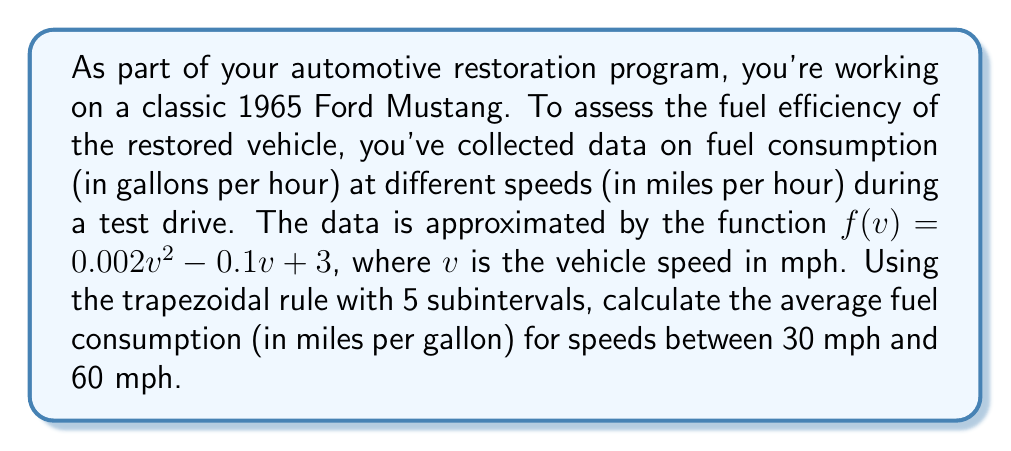What is the answer to this math problem? To solve this problem, we'll follow these steps:

1) The fuel efficiency (miles per gallon) is the inverse of fuel consumption (gallons per mile). We need to integrate $\frac{1}{f(v)}$ with respect to $v$.

2) We'll use the trapezoidal rule with 5 subintervals. The formula is:

   $$\int_{a}^{b} g(x) dx \approx \frac{h}{2}[g(x_0) + 2g(x_1) + 2g(x_2) + 2g(x_3) + 2g(x_4) + g(x_5)]$$

   where $h = \frac{b-a}{n}$, $n$ is the number of subintervals, and $x_i = a + ih$.

3) In our case, $a = 30$, $b = 60$, $n = 5$, so $h = \frac{60-30}{5} = 6$.

4) We need to evaluate $g(v) = \frac{1}{f(v)} = \frac{1}{0.002v^2 - 0.1v + 3}$ at $v = 30, 36, 42, 48, 54, 60$.

5) Calculating these values:
   $g(30) = \frac{1}{0.002(30)^2 - 0.1(30) + 3} = 0.4545$
   $g(36) = 0.4926$
   $g(42) = 0.5102$
   $g(48) = 0.5051$
   $g(54) = 0.4808$
   $g(60) = 0.4444$

6) Applying the trapezoidal rule:
   $$\int_{30}^{60} \frac{1}{f(v)} dv \approx \frac{6}{2}[0.4545 + 2(0.4926 + 0.5102 + 0.5051 + 0.4808) + 0.4444]$$
   $$= 3[0.4545 + 3.9774 + 0.4444] = 3(4.8763) = 14.6289$$

7) This integral represents the total miles driven per gallon of fuel consumed. To get the average fuel efficiency, we divide by the speed range (60 - 30 = 30 mph):

   Average MPG = $\frac{14.6289}{30} = 0.4876$

8) The reciprocal of this gives us the average fuel consumption in gallons per mile, which we can convert to miles per gallon:

   Average Fuel Efficiency = $\frac{1}{0.4876} = 2.0508$ miles per gallon
Answer: The average fuel efficiency of the restored 1965 Ford Mustang for speeds between 30 mph and 60 mph is approximately 2.05 miles per gallon. 